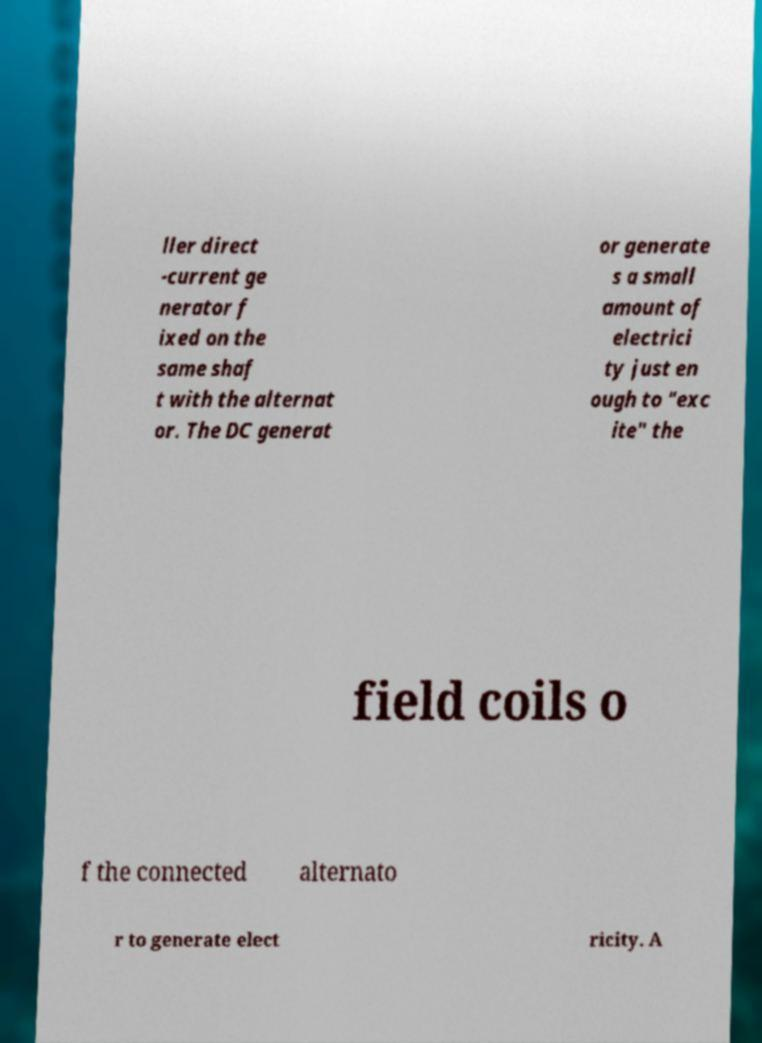What messages or text are displayed in this image? I need them in a readable, typed format. ller direct -current ge nerator f ixed on the same shaf t with the alternat or. The DC generat or generate s a small amount of electrici ty just en ough to "exc ite" the field coils o f the connected alternato r to generate elect ricity. A 